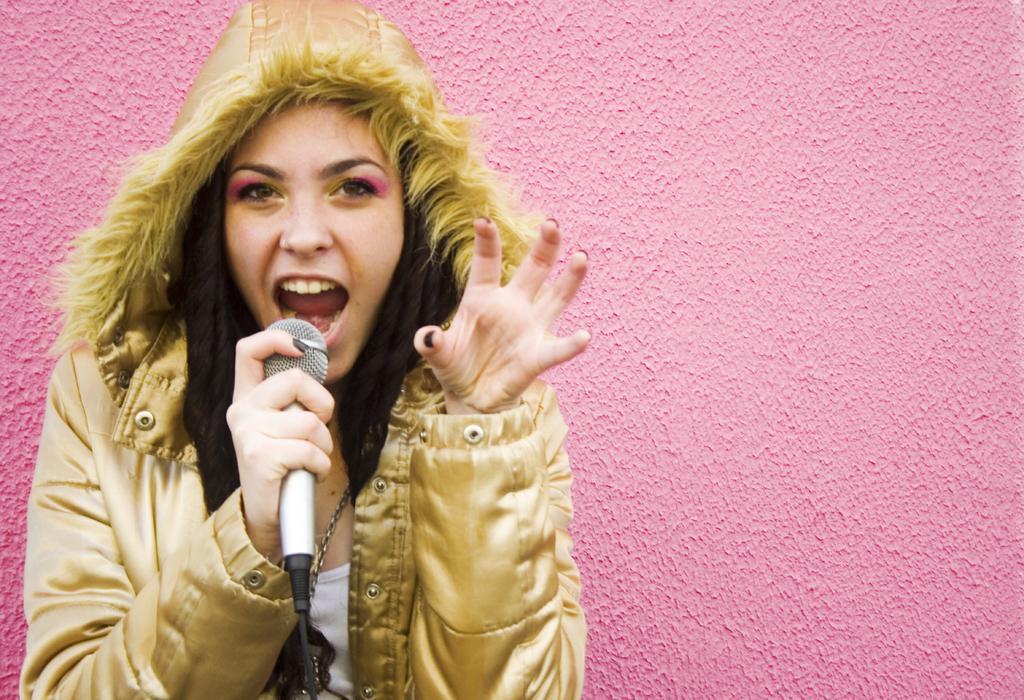How would you summarize this image in a sentence or two? there is a woman holding a microphone. 